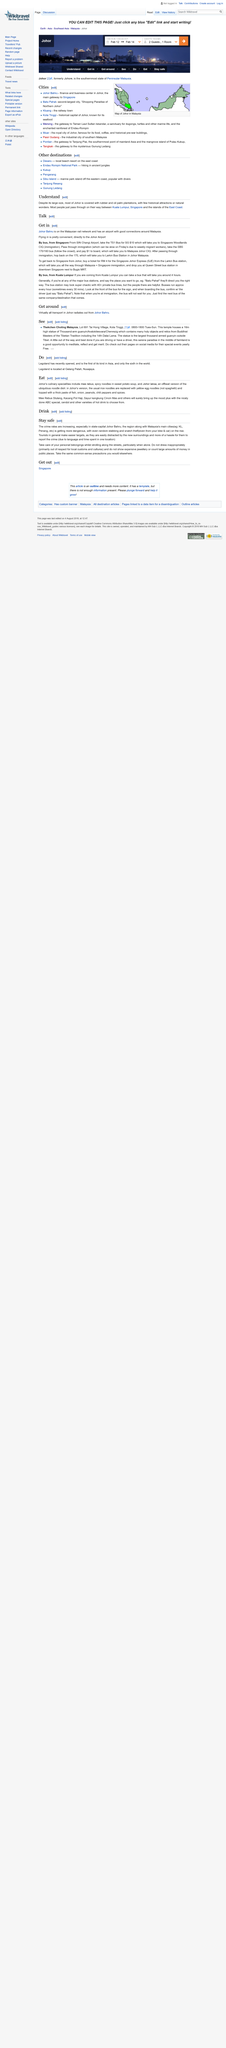Highlight a few significant elements in this photo. Yes, you can get mee rebus to eat in Johor. Johor is located in Malaysia. When strolling along streets, it is crucial to take care of your personal belongings to ensure their safety and security. Tourists are often made easy targets for crime due to their unfamiliarity with the area and lack of knowledge about local conditions. Johor Bahru is on the Malaysian rail network. 